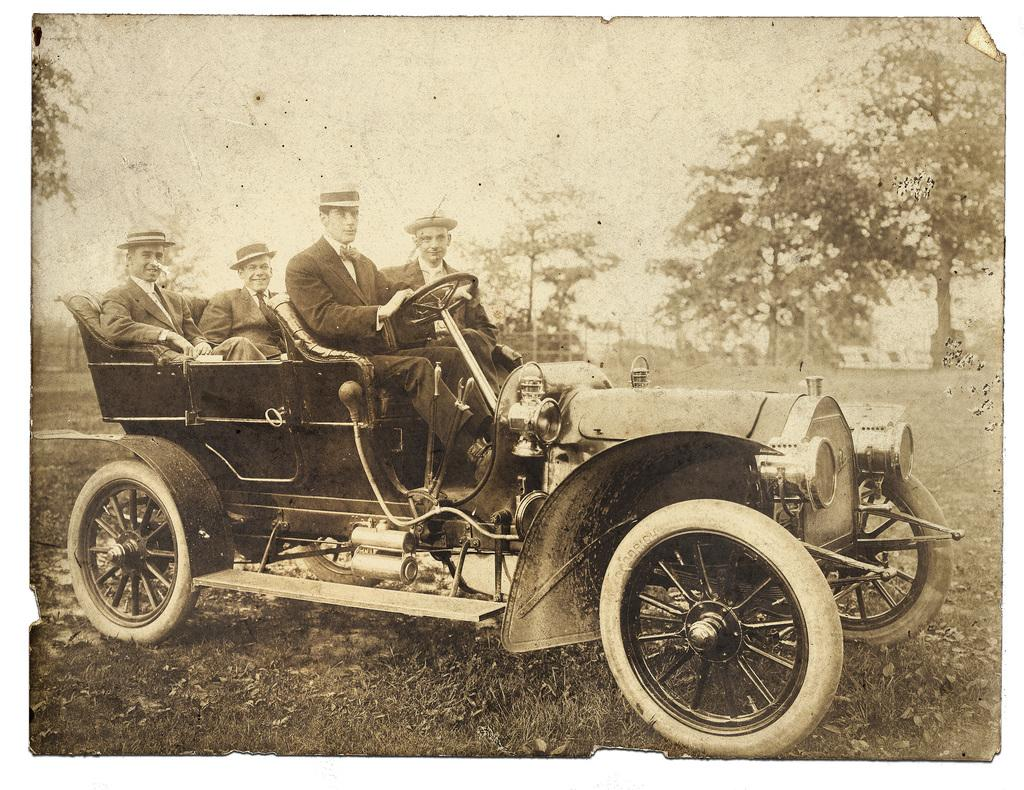What is the color scheme of the image? The image is in black and white. What are the people in the image doing? The people are sitting in a car. What can be seen in the background of the image? There are trees, a boundary, and the sky visible in the background of the image. What type of border is being smashed by the people in the image? There is no border being smashed in the image, nor are there any people smashing anything. 